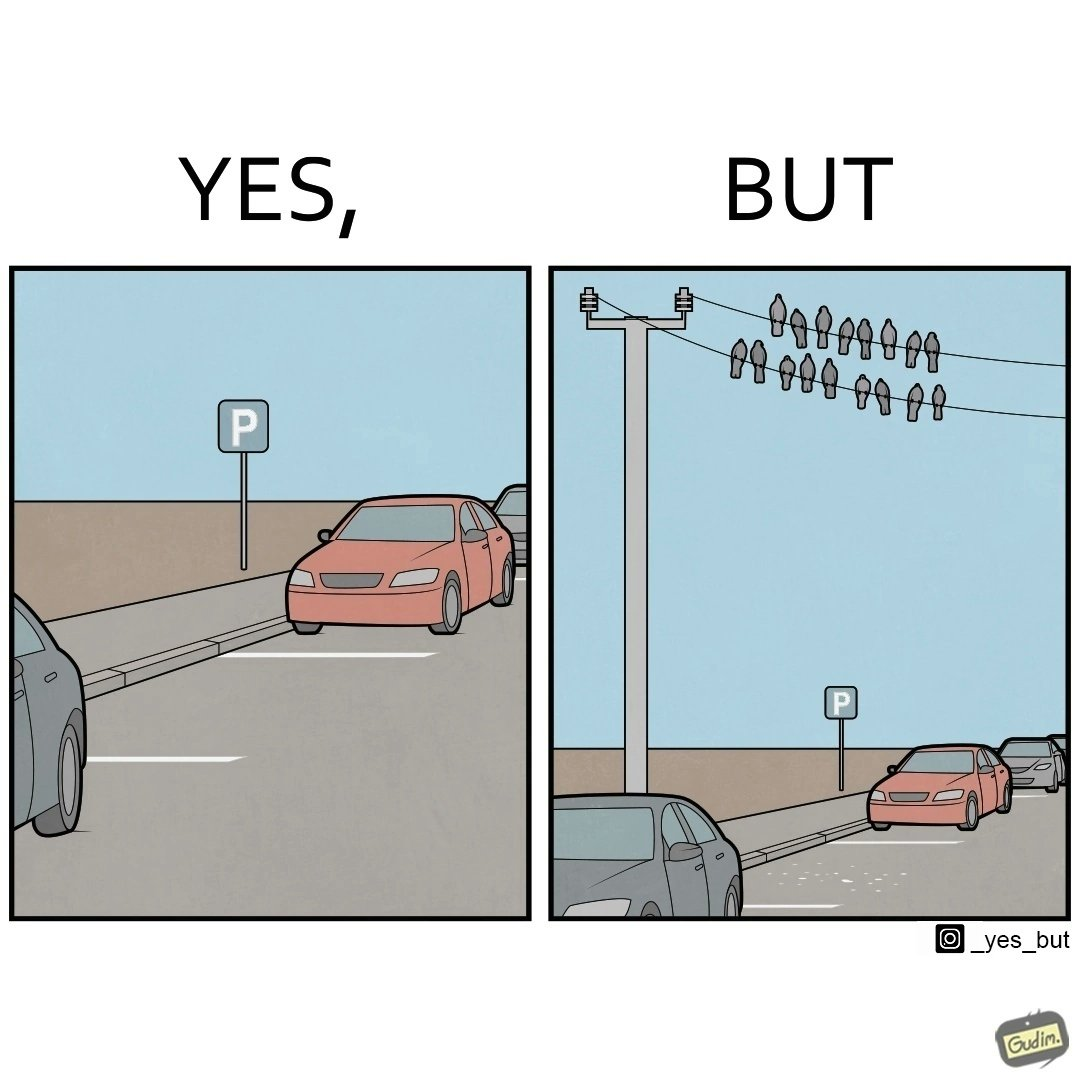Describe what you see in the left and right parts of this image. In the left part of the image: There is a parking place where few cars are standing leaving a place in middle. In the right part of the image: Some crows are sitting on a wire which is above the parking area and the crows are making that place dirty. 